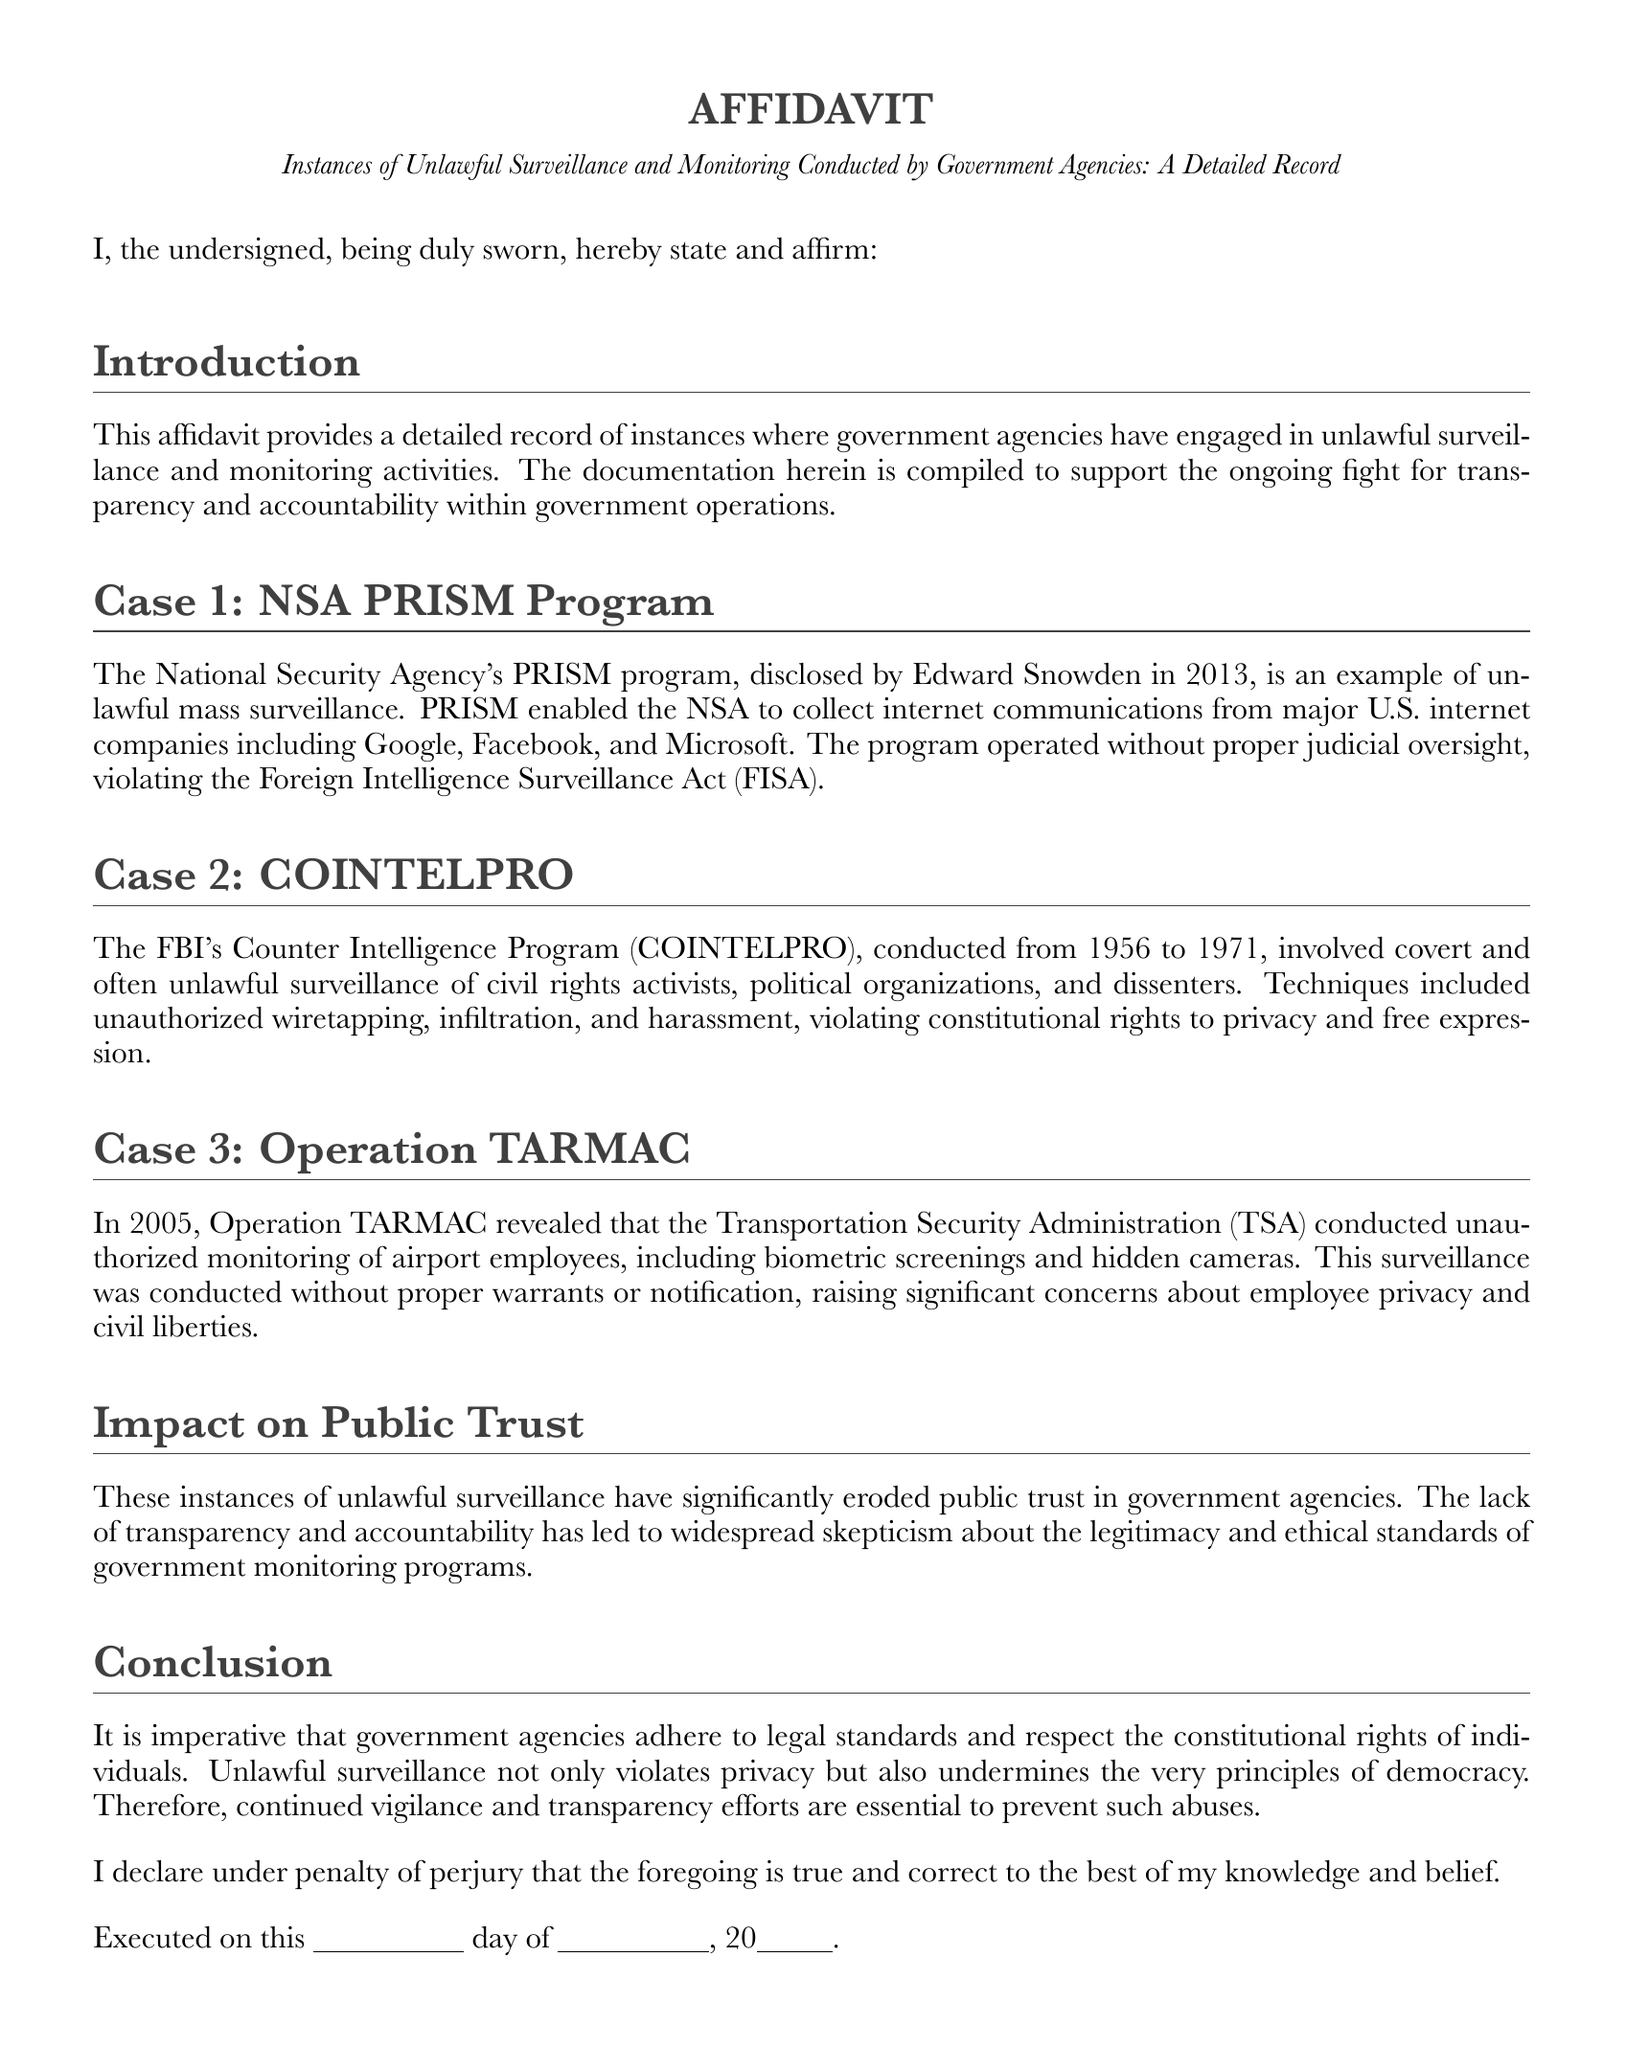What is the main purpose of the affidavit? The affidavit aims to provide a detailed record of unlawful surveillance and monitoring conducted by government agencies to support transparency and accountability.
Answer: Transparency and accountability Who disclosed the NSA PRISM program? The NSA PRISM program was disclosed by Edward Snowden.
Answer: Edward Snowden What years did COINTELPRO operate? COINTELPRO operated from 1956 to 1971.
Answer: 1956 to 1971 What organization conducted Operation TARMAC? The organization that conducted Operation TARMAC is the Transportation Security Administration (TSA).
Answer: Transportation Security Administration What type of rights did COINTELPRO violate? COINTELPRO violated constitutional rights to privacy and free expression.
Answer: Privacy and free expression What is a significant impact of unlawful surveillance mentioned? A significant impact mentioned is the erosion of public trust in government agencies.
Answer: Erosion of public trust What does the affidavit declare under penalty of? The affidavit declares under penalty of perjury.
Answer: Perjury What is emphasized as necessary to prevent abuses? Continued vigilance and transparency efforts are emphasized as necessary to prevent abuses.
Answer: Vigilance and transparency efforts 